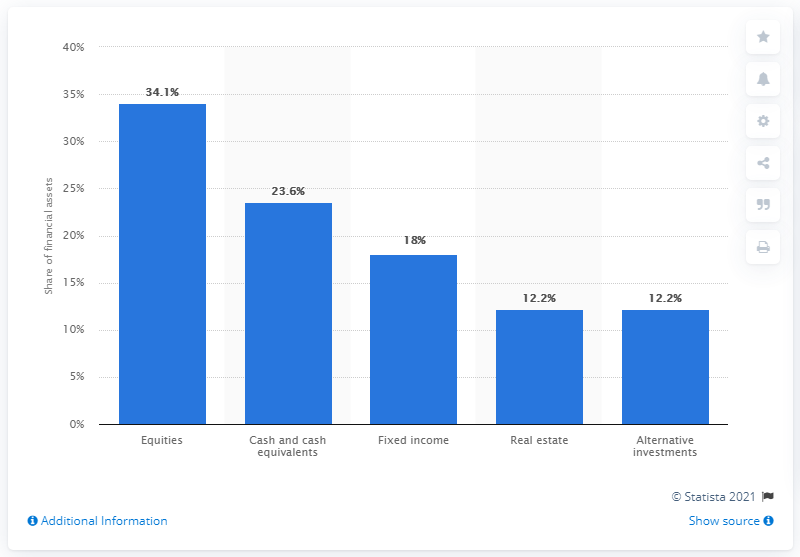Identify some key points in this picture. In the first quarter of 2015, 34.1% of the financial assets of a particular group or entity was invested in equities. 